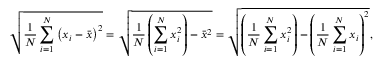<formula> <loc_0><loc_0><loc_500><loc_500>{ \sqrt { { \frac { 1 } { N } } \sum _ { i = 1 } ^ { N } \left ( x _ { i } - { \bar { x } } \right ) ^ { 2 } } } = { \sqrt { { \frac { 1 } { N } } \left ( \sum _ { i = 1 } ^ { N } x _ { i } ^ { 2 } \right ) - { \bar { x } } ^ { 2 } } } = { \sqrt { \left ( { \frac { 1 } { N } } \sum _ { i = 1 } ^ { N } x _ { i } ^ { 2 } \right ) - \left ( { \frac { 1 } { N } } \sum _ { i = 1 } ^ { N } x _ { i } \right ) ^ { 2 } } } ,</formula> 